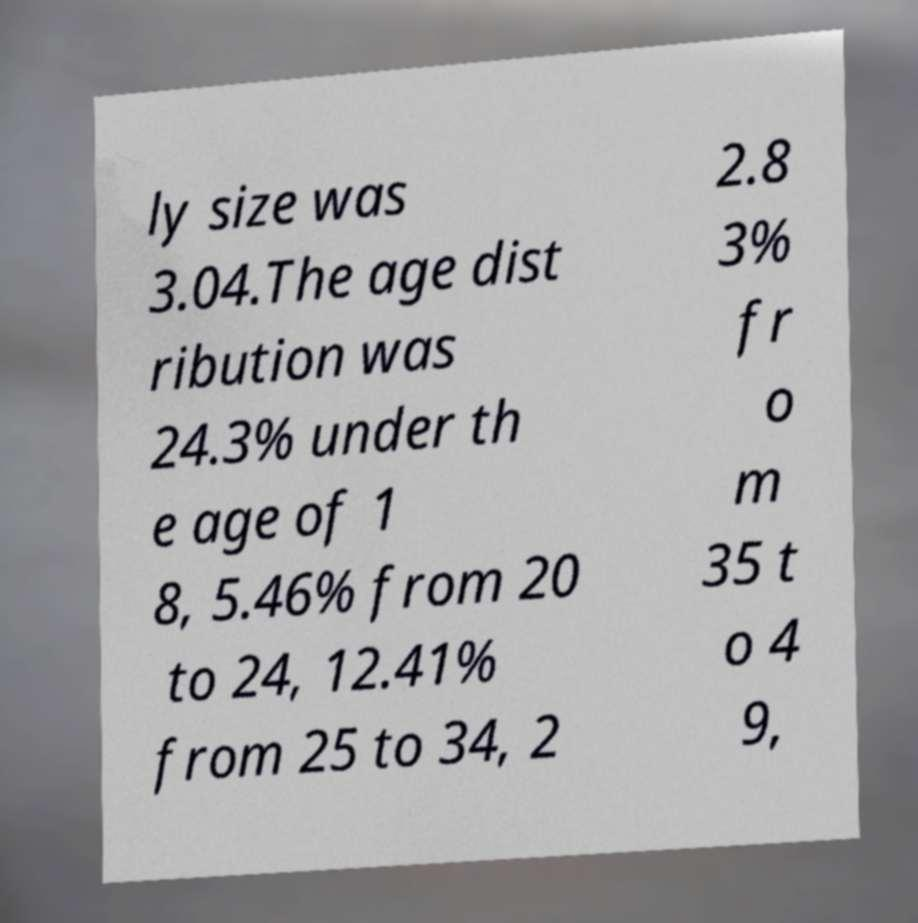There's text embedded in this image that I need extracted. Can you transcribe it verbatim? ly size was 3.04.The age dist ribution was 24.3% under th e age of 1 8, 5.46% from 20 to 24, 12.41% from 25 to 34, 2 2.8 3% fr o m 35 t o 4 9, 